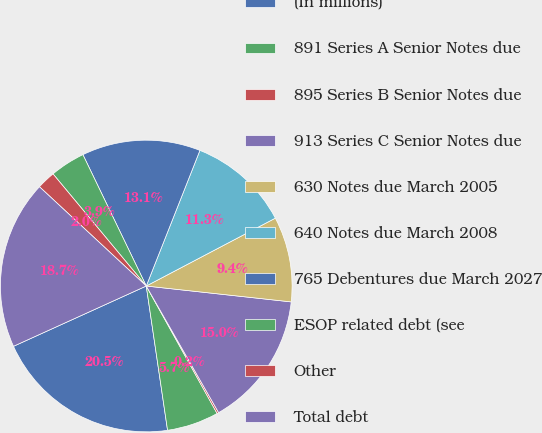<chart> <loc_0><loc_0><loc_500><loc_500><pie_chart><fcel>(In millions)<fcel>891 Series A Senior Notes due<fcel>895 Series B Senior Notes due<fcel>913 Series C Senior Notes due<fcel>630 Notes due March 2005<fcel>640 Notes due March 2008<fcel>765 Debentures due March 2027<fcel>ESOP related debt (see<fcel>Other<fcel>Total debt<nl><fcel>20.55%<fcel>5.74%<fcel>0.19%<fcel>15.0%<fcel>9.44%<fcel>11.3%<fcel>13.15%<fcel>3.89%<fcel>2.04%<fcel>18.7%<nl></chart> 